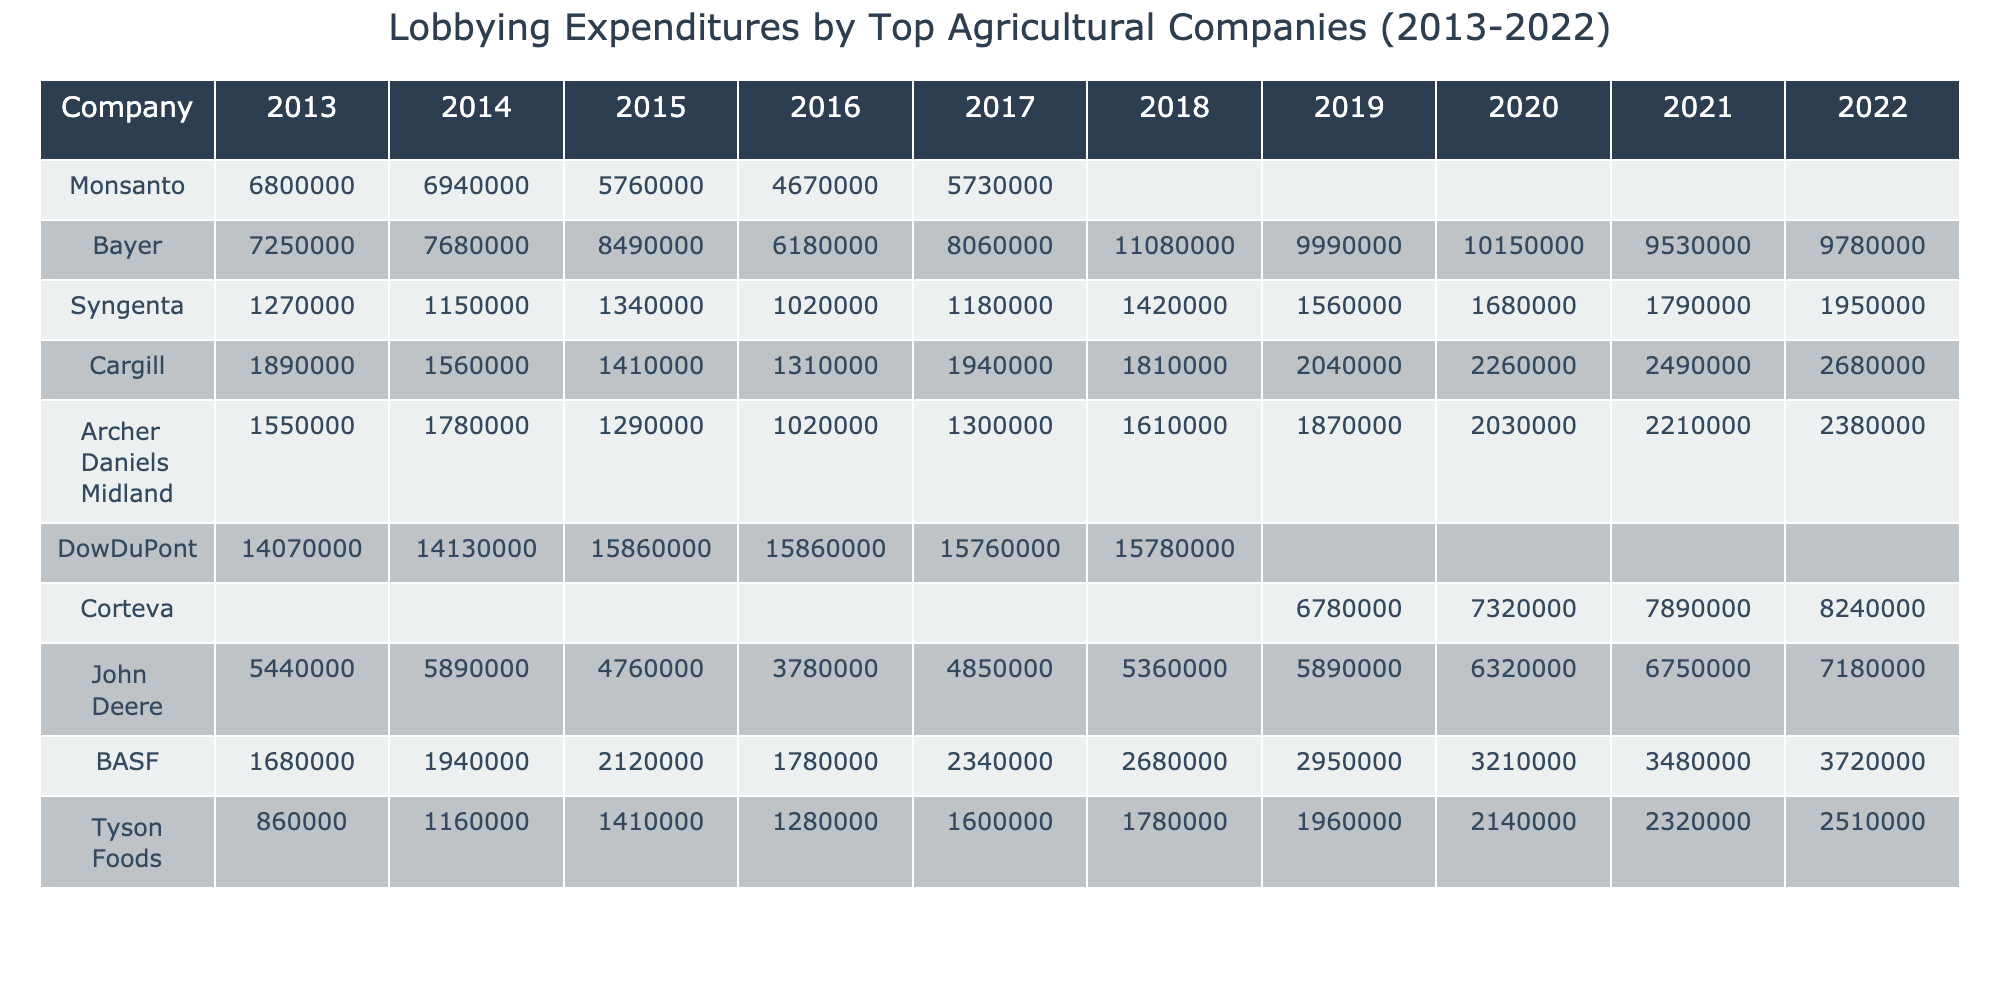What were the lobbying expenditures of Monsanto in 2013? The table shows that Monsanto spent $6,800,000 in lobbying expenditures in 2013.
Answer: $6,800,000 Which company had the highest lobbying expenditures in 2018? By comparing the expenditures in 2018, DowDuPont had the highest amount at $15,780,000.
Answer: DowDuPont What is the total lobbying expenditure for Bayer from 2013 to 2022? To find the total for Bayer, I will sum up the values: 7,250,000 + 7,680,000 + 8,490,000 + 6,180,000 + 8,060,000 + 11,080,000 + 9,990,000 + 10,150,000 + 9,530,000 + 9,780,000 = 78,270,000.
Answer: $78,270,000 Did Syngenta's lobbying expenditures increase every year from 2013 to 2022? Observing the values, while Syngenta does show a general increase, there were fluctuations: notably a decrease in 2016. Therefore, the statement is false.
Answer: No What is the average lobbying expenditure for Cargill between 2013 and 2022? The values for Cargill from 2013 to 2022 are: 1,890,000, 1,560,000, 1,410,000, 1,310,000, 1,940,000, 1,810,000, 2,040,000, 2,260,000, 2,490,000, 2,680,000, which sums to 19,860,000. There are 10 data points, so the average is 19,860,000 / 10 = 1,986,000.
Answer: $1,986,000 Which company showed the greatest volatility in lobbying expenditures over the years? DowDuPont appears to show a significant increase from 2013 to 2018, followed by data gaps, indicating high volatility in reporting while other companies showed more consistent trends.
Answer: DowDuPont What was the difference in lobbying expenditures for John Deere between 2013 and 2022? For John Deere, the expenditure in 2022 is 7,180,000 and in 2013 is 5,440,000. The difference is 7,180,000 - 5,440,000 = 1,740,000.
Answer: $1,740,000 Did Tyson Foods ever exceed $2 million in lobbying expenditures? Examining the values for Tyson Foods, the highest value recorded is $2,514,000 in 2022, hence it did exceed $2 million.
Answer: Yes What was the trend in lobbying expenditures for Corteva from its initiation in 2019 to 2022? Corteva's expenditures began at $6,780,000 in 2019 and increased each subsequent year to $8,240,000 in 2022, indicating an upward trend.
Answer: Upward trend Which company had the lowest total lobbying expenditures from 2013 to 2022? By calculating the totals for each company, Tyson Foods had the lowest total: 860,000 + 1,160,000 + 1,410,000 + 1,280,000 + 1,600,000 + 1,780,000 + 1,960,000 + 2,140,000 + 2,320,000 + 2,510,000 = 14,390,000.
Answer: Tyson Foods 